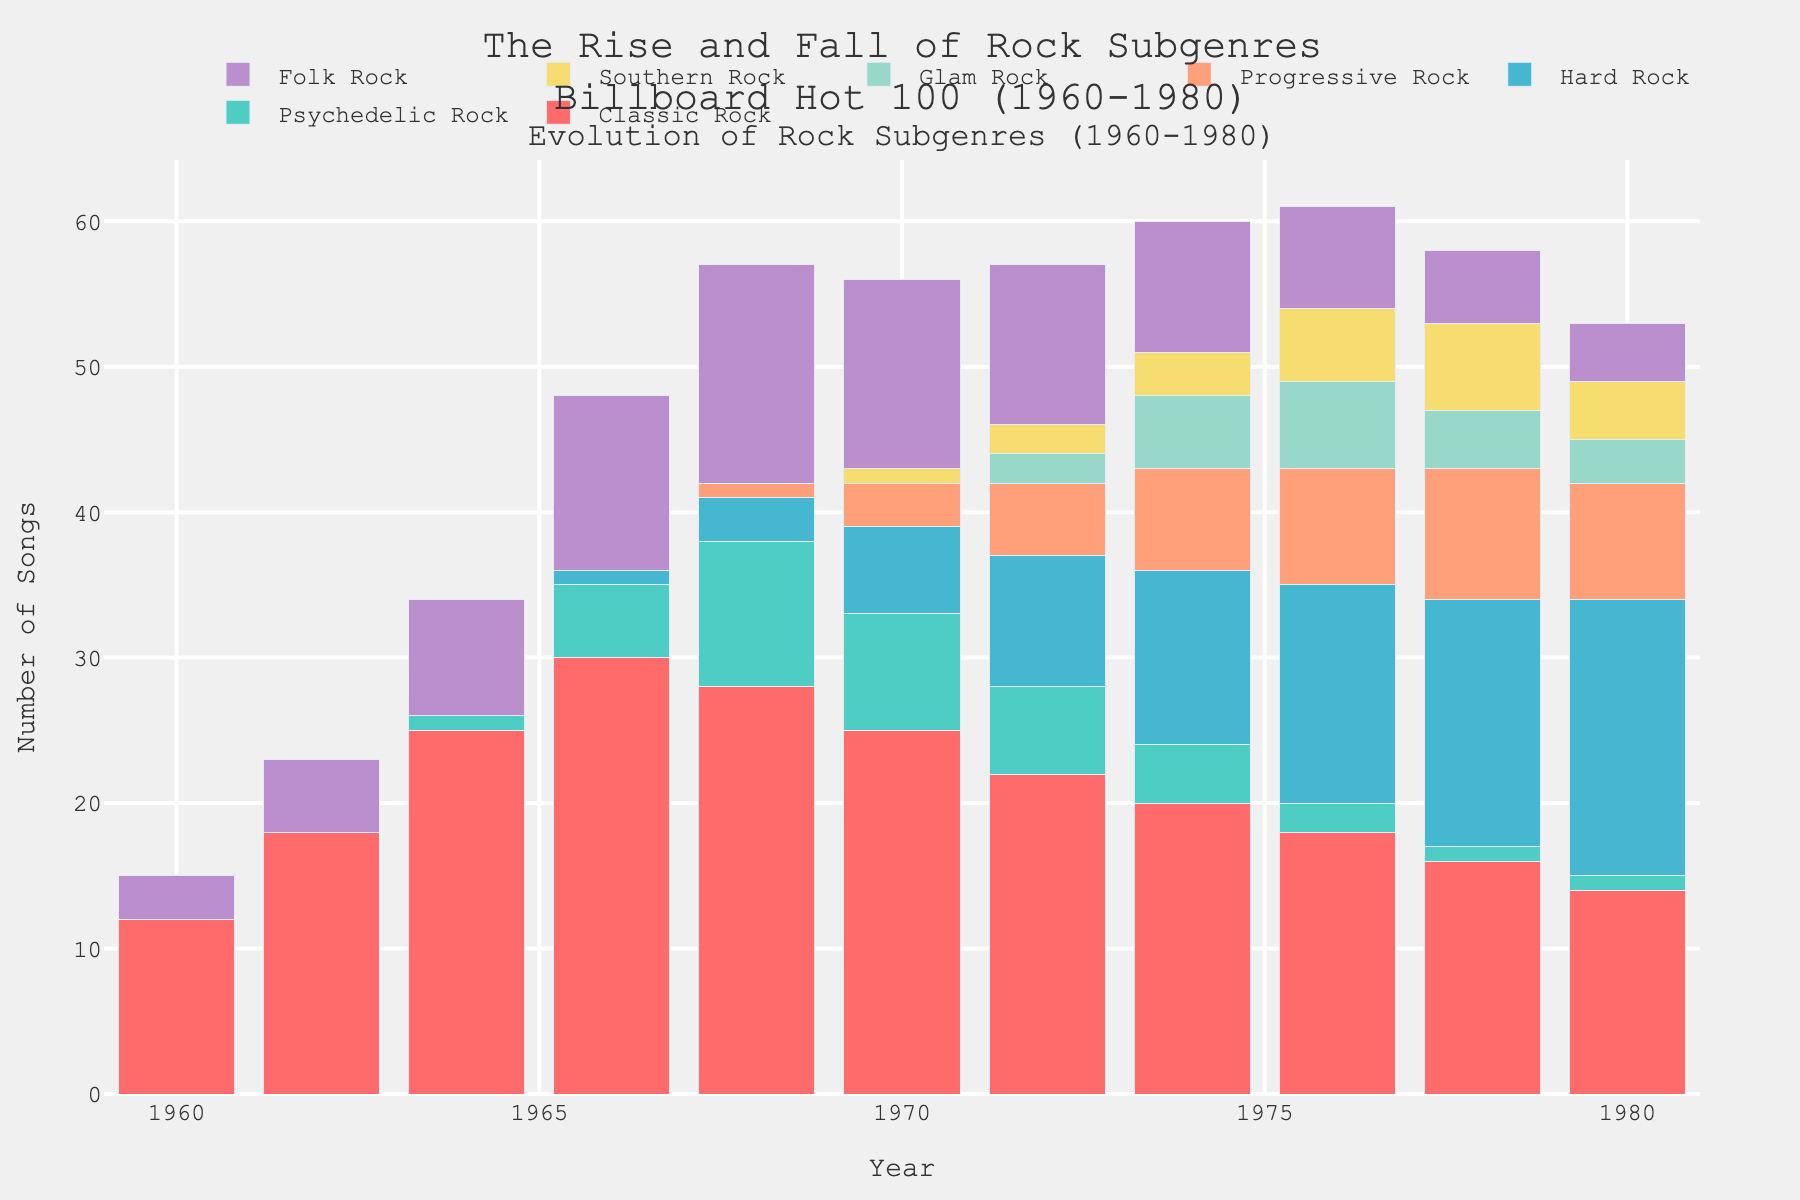What is the trend of Classic Rock from 1960 to 1980? The bar heights for Classic Rock start from 12 in 1960, increase to a peak of 30 in 1966, and then gradually decrease back to 14 in 1980.
Answer: A rise until 1966, then a gradual decline In what year did Psychedelic Rock first appear in the Billboard Hot 100 charts? The first non-zero bar for Psychedelic Rock is in 1964, with a value of 1.
Answer: 1964 Which subgenre had the highest number of songs in 1980? In 1980, the Hard Rock bar has the highest value at 19, compared to other subgenres.
Answer: Hard Rock How many more Folk Rock songs were on the charts in 1968 compared to 1960? In 1968, Folk Rock has 15 songs, and in 1960, it has 3 songs. The difference is 15 - 3.
Answer: 12 Which year had the highest combined number of songs for Hard Rock and Progressive Rock? Looking at the bars for each year, the highest combined number appears in 1980, with 19 (Hard Rock) + 8 (Progressive Rock) = 27.
Answer: 1980 Compare the number of Southern Rock songs in 1976 and 1980. Which year had more? The bar for Southern Rock in 1976 is 5, while in 1980 it is 4.
Answer: 1976 What is the ratio of the highest number of Classic Rock songs to the highest number of Folk Rock songs? The highest number of Classic Rock songs is 30 in 1966, and the highest number of Folk Rock songs is 15 in 1968. The ratio is 30 / 15.
Answer: 2:1 During which year did Progressive Rock first appear on the charts? The first year with a non-zero bar for Progressive Rock is 1968, showing a value of 1.
Answer: 1968 Between 1968 and 1980, in which year was Psychedelic Rock most prominent? The bar is highest for Psychedelic Rock in 1968, with a value of 10.
Answer: 1968 Calculate the average number of Glam Rock songs from 1974 to 1980. Adding the values for Glam Rock from 1974 (5), 1976 (6), 1978 (4), and 1980 (3) gives a total of 18. There are 4 years, so the average is 18 / 4.
Answer: 4.5 